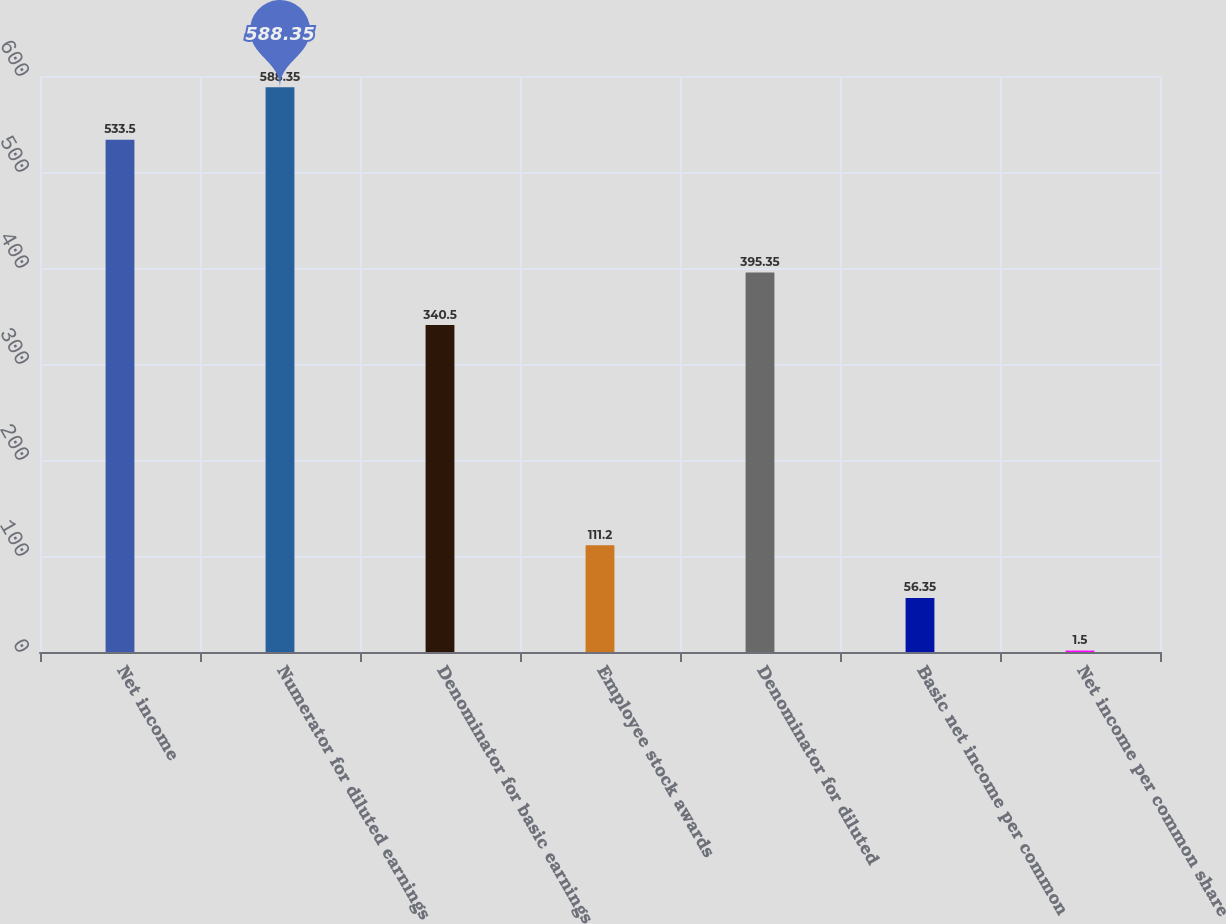<chart> <loc_0><loc_0><loc_500><loc_500><bar_chart><fcel>Net income<fcel>Numerator for diluted earnings<fcel>Denominator for basic earnings<fcel>Employee stock awards<fcel>Denominator for diluted<fcel>Basic net income per common<fcel>Net income per common share<nl><fcel>533.5<fcel>588.35<fcel>340.5<fcel>111.2<fcel>395.35<fcel>56.35<fcel>1.5<nl></chart> 